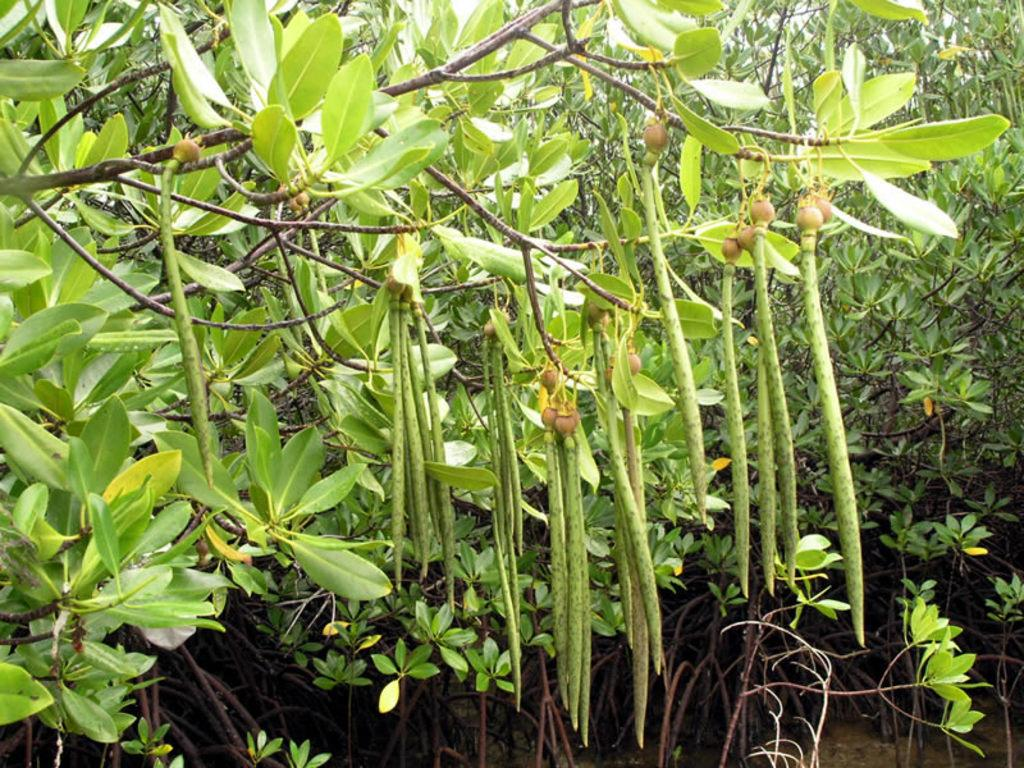What type of vegetation can be seen in the image? There are many plants and trees in the image. Are there any edible parts of the plants visible in the image? Yes, fruits are visible in the image. What can be found at the bottom of the image? There are sticks at the bottom of the image. How many errors can be found in the image? There is no indication of any errors in the image, as it is a photograph of plants, trees, fruits, and sticks. 